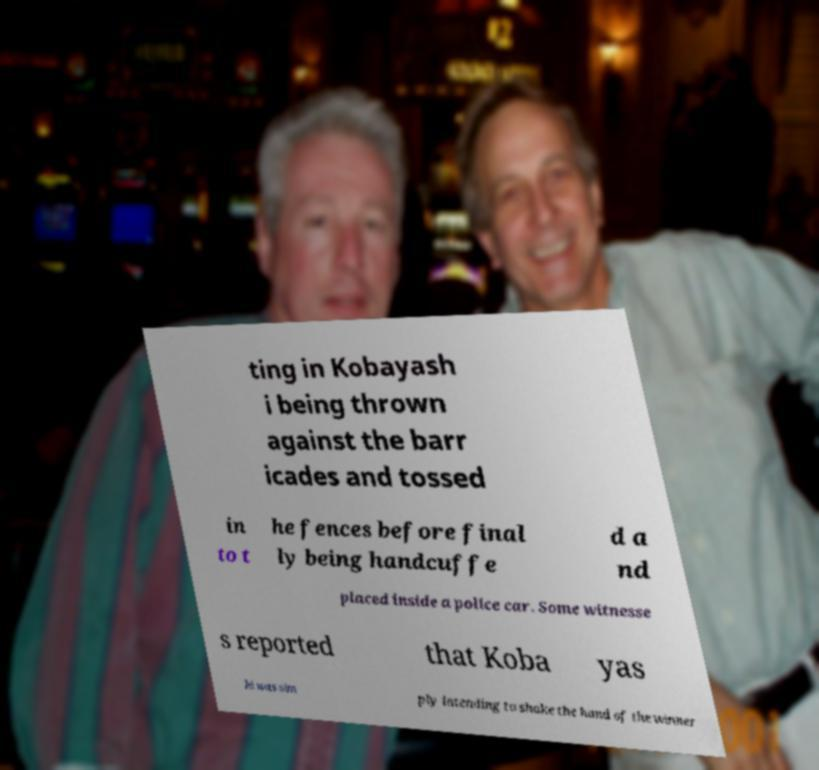Could you extract and type out the text from this image? ting in Kobayash i being thrown against the barr icades and tossed in to t he fences before final ly being handcuffe d a nd placed inside a police car. Some witnesse s reported that Koba yas hi was sim ply intending to shake the hand of the winner 